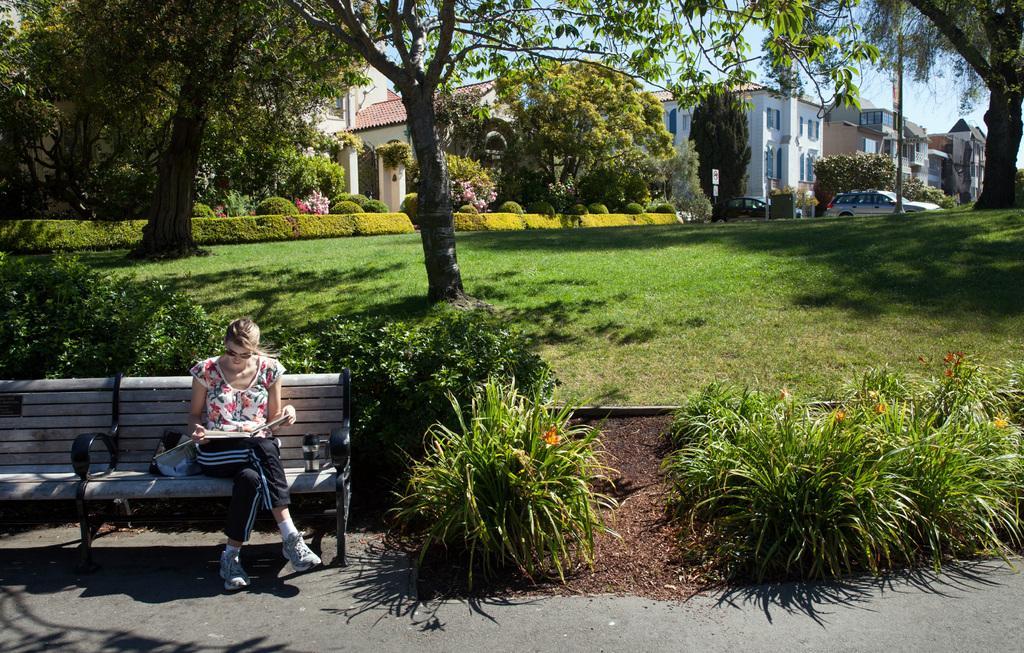Describe this image in one or two sentences. The photo is taken outside a building. In the left a lady is sitting on bench she is reading a book , the book is on her lap. There are many plant , trees. This is looking like a park. In the background there are buildings, car. 